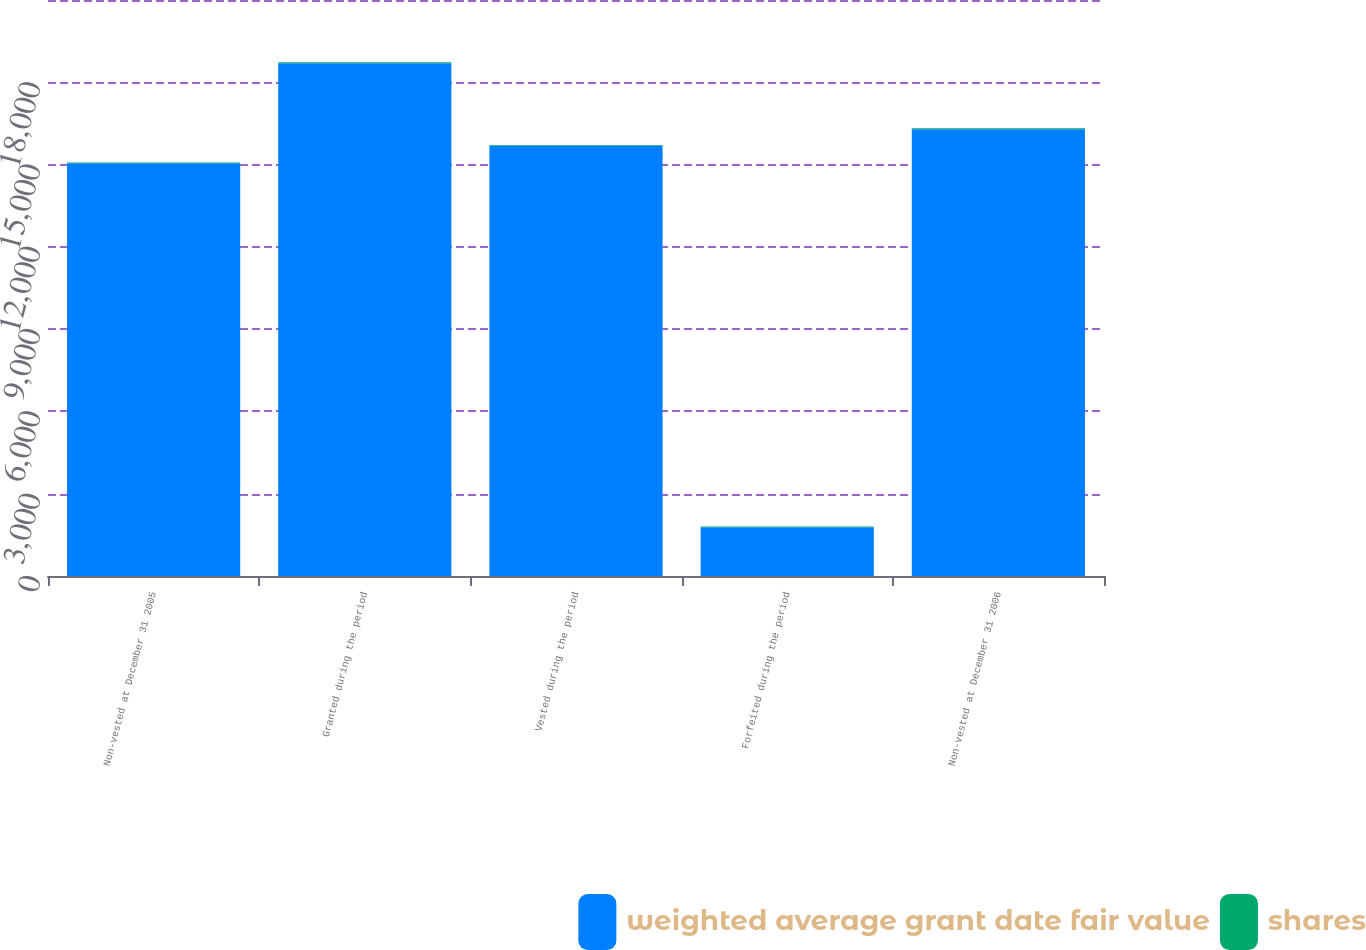Convert chart. <chart><loc_0><loc_0><loc_500><loc_500><stacked_bar_chart><ecel><fcel>Non-vested at December 31 2005<fcel>Granted during the period<fcel>Vested during the period<fcel>Forfeited during the period<fcel>Non-vested at December 31 2006<nl><fcel>weighted average grant date fair value<fcel>15052<fcel>18698<fcel>15685<fcel>1774<fcel>16291<nl><fcel>shares<fcel>22.68<fcel>33.12<fcel>26.49<fcel>27.94<fcel>30.8<nl></chart> 